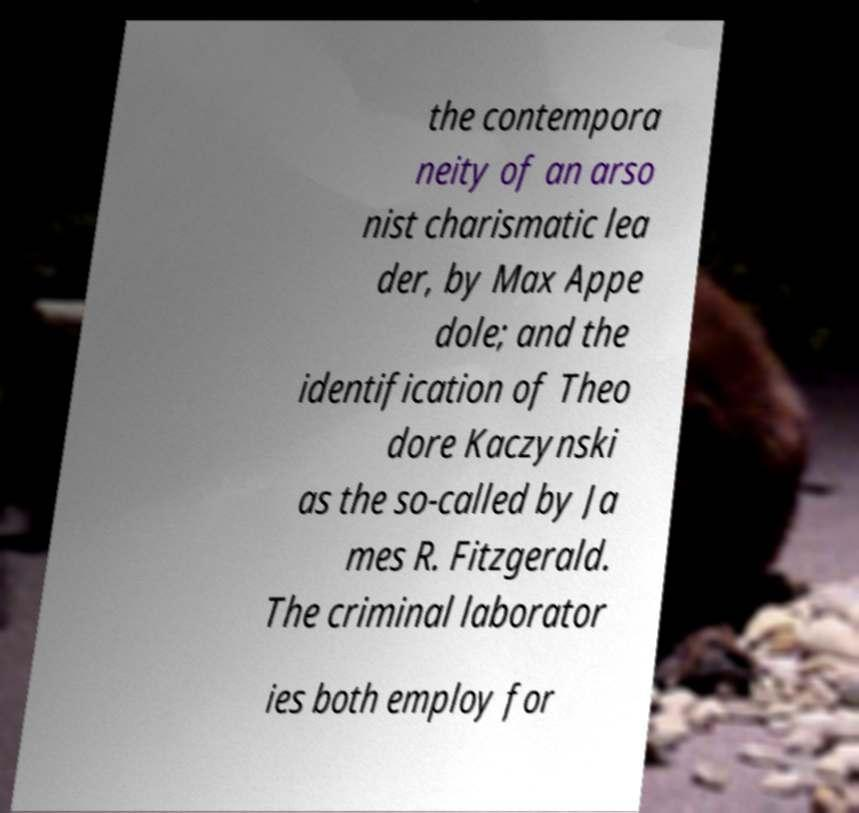Can you accurately transcribe the text from the provided image for me? the contempora neity of an arso nist charismatic lea der, by Max Appe dole; and the identification of Theo dore Kaczynski as the so-called by Ja mes R. Fitzgerald. The criminal laborator ies both employ for 